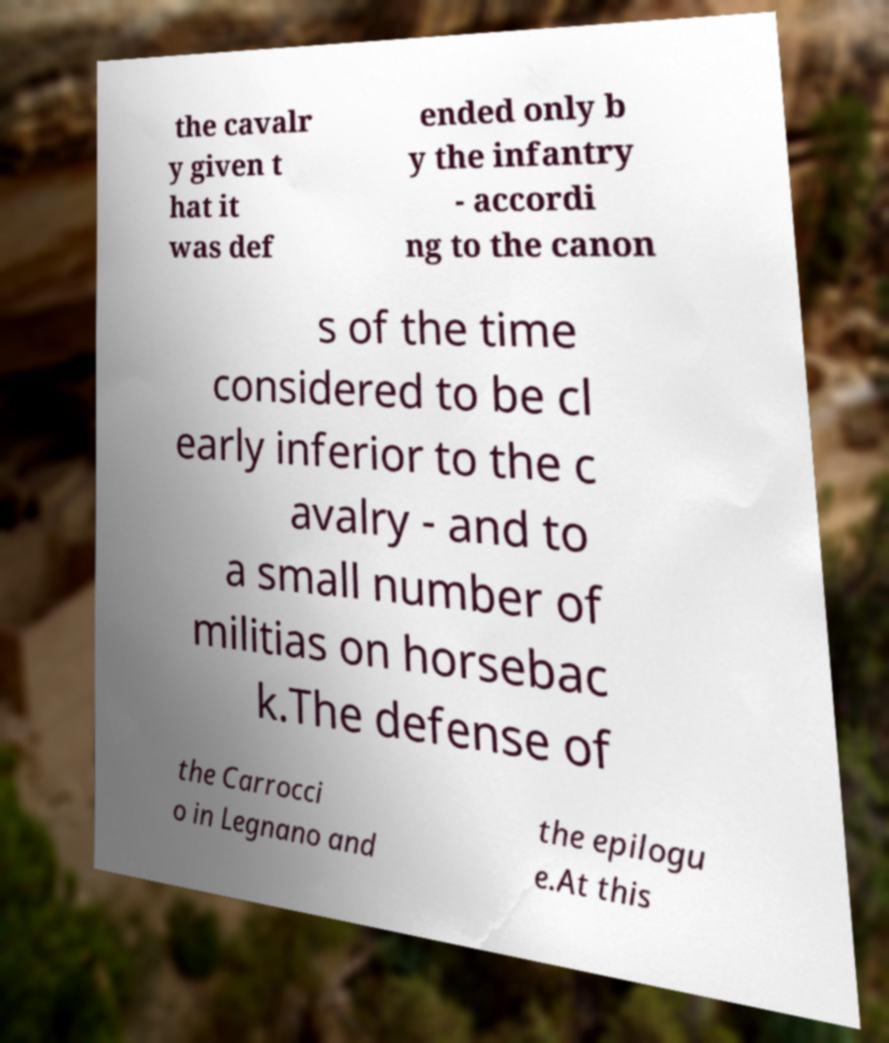Can you read and provide the text displayed in the image?This photo seems to have some interesting text. Can you extract and type it out for me? the cavalr y given t hat it was def ended only b y the infantry - accordi ng to the canon s of the time considered to be cl early inferior to the c avalry - and to a small number of militias on horsebac k.The defense of the Carrocci o in Legnano and the epilogu e.At this 